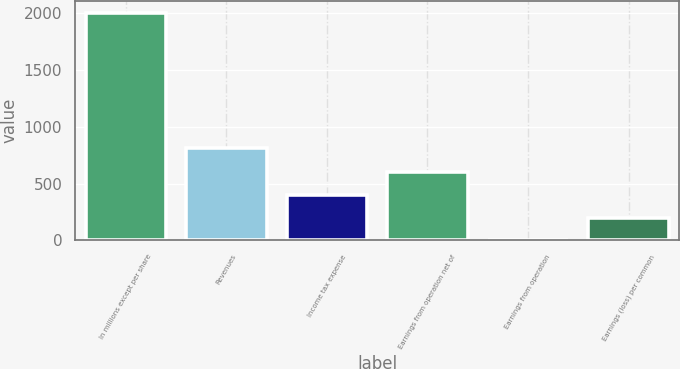Convert chart. <chart><loc_0><loc_0><loc_500><loc_500><bar_chart><fcel>In millions except per share<fcel>Revenues<fcel>Income tax expense<fcel>Earnings from operation net of<fcel>Earnings from operation<fcel>Earnings (loss) per common<nl><fcel>2006<fcel>816<fcel>401.25<fcel>601.84<fcel>0.07<fcel>200.66<nl></chart> 